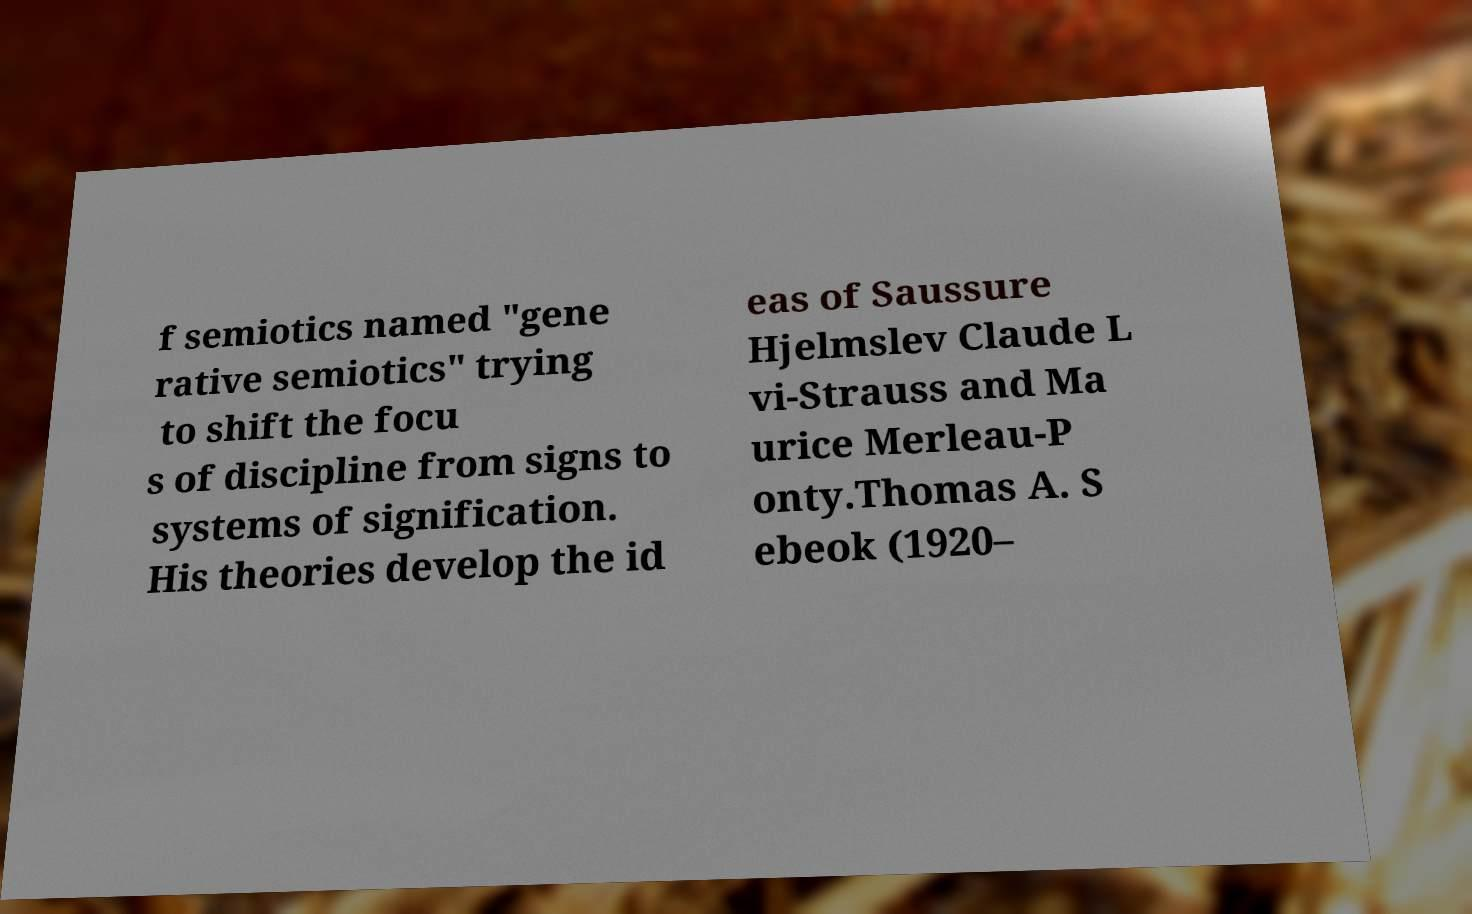For documentation purposes, I need the text within this image transcribed. Could you provide that? f semiotics named "gene rative semiotics" trying to shift the focu s of discipline from signs to systems of signification. His theories develop the id eas of Saussure Hjelmslev Claude L vi-Strauss and Ma urice Merleau-P onty.Thomas A. S ebeok (1920– 